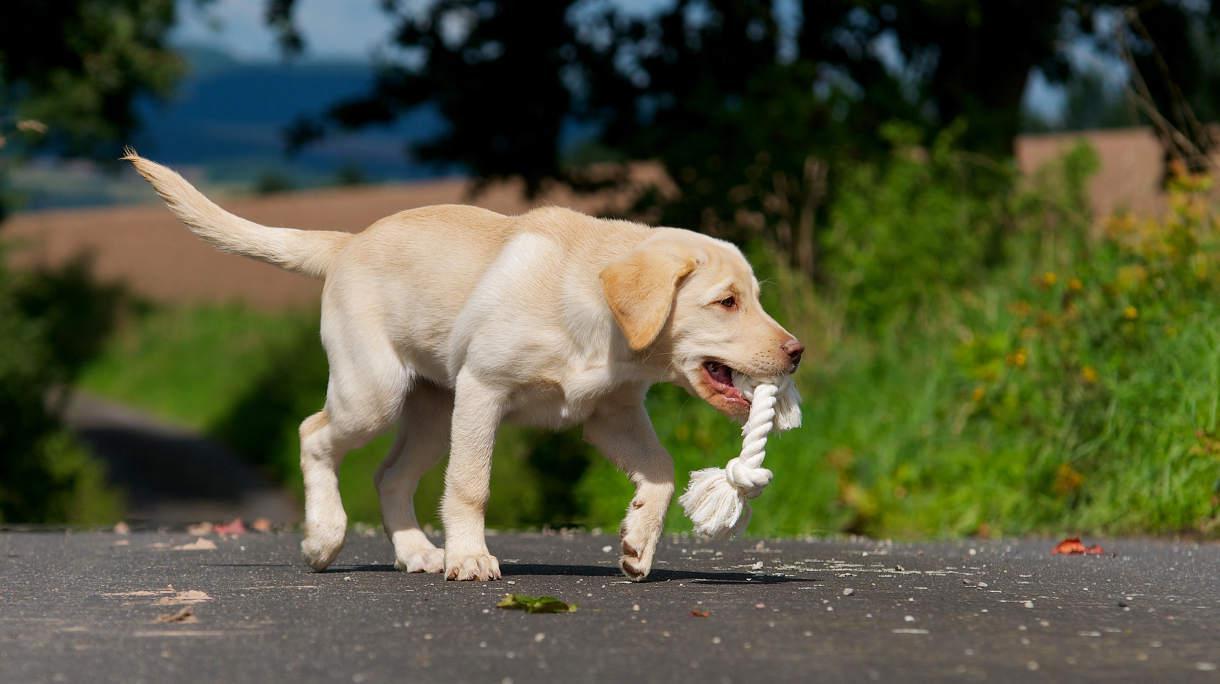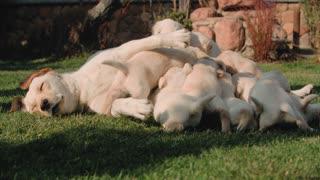The first image is the image on the left, the second image is the image on the right. Assess this claim about the two images: "One image features exactly two dogs relaxing on the grass.". Correct or not? Answer yes or no. No. The first image is the image on the left, the second image is the image on the right. Given the left and right images, does the statement "In one of the images there are exactly two golden labs interacting with each other." hold true? Answer yes or no. No. 